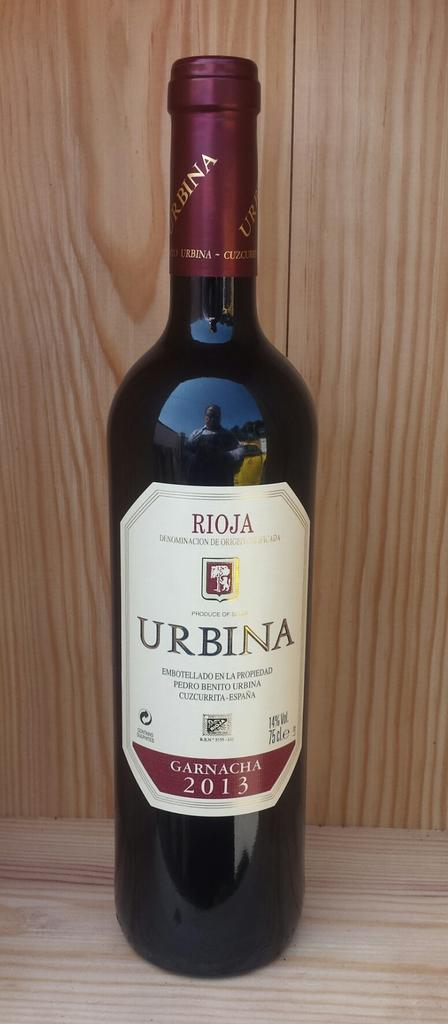Provide a one-sentence caption for the provided image. A bottle of wine with Urbina on the label. 